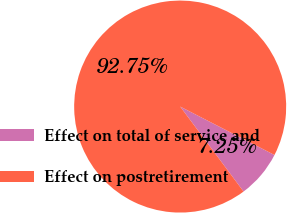Convert chart to OTSL. <chart><loc_0><loc_0><loc_500><loc_500><pie_chart><fcel>Effect on total of service and<fcel>Effect on postretirement<nl><fcel>7.25%<fcel>92.75%<nl></chart> 